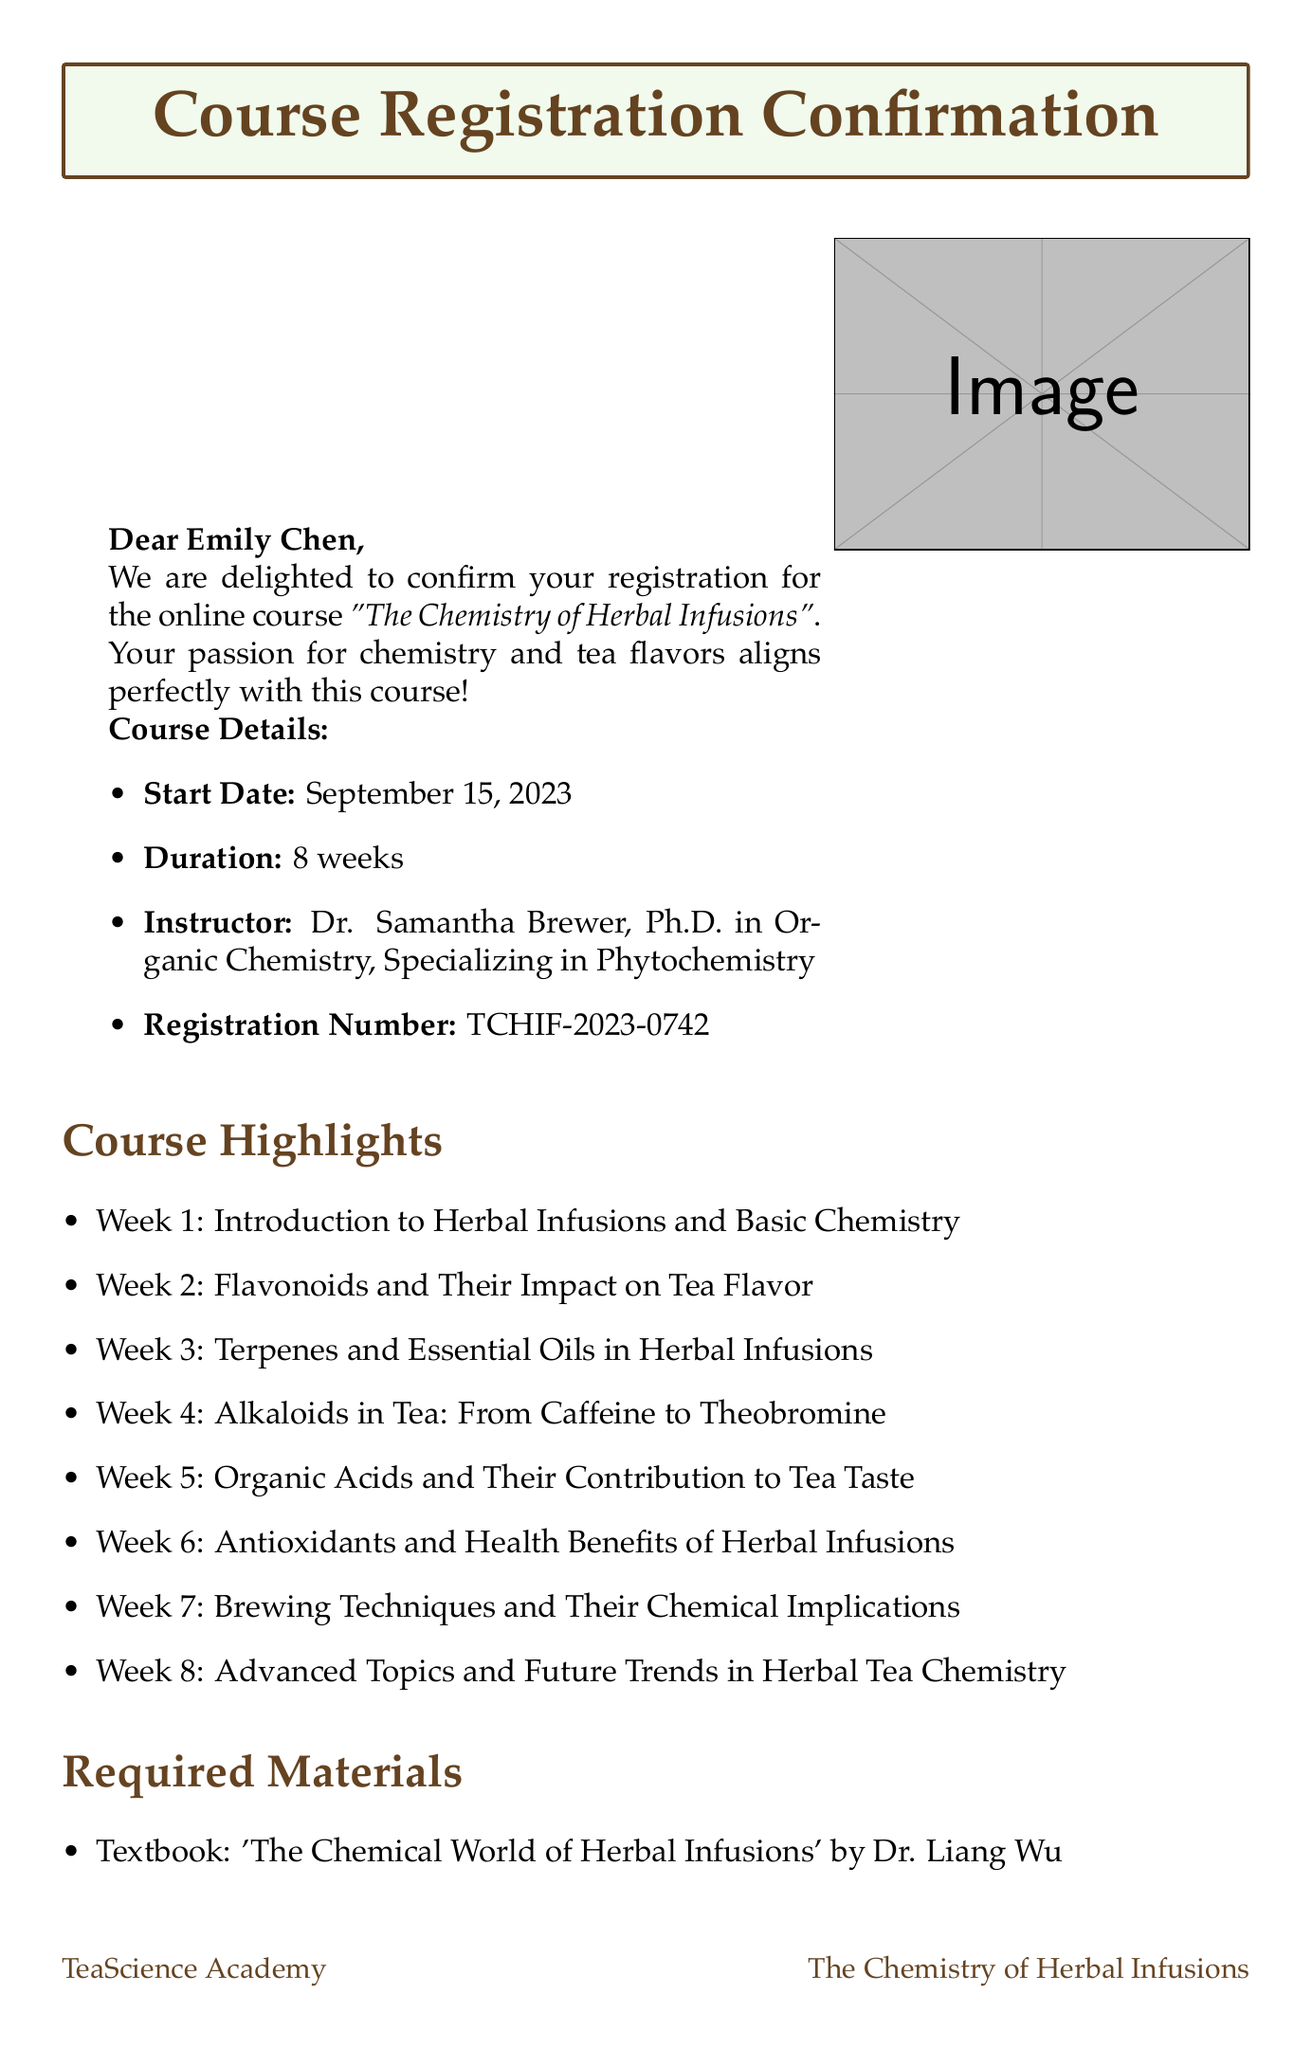What is the course title? The course title is specifically mentioned in the document as "The Chemistry of Herbal Infusions".
Answer: The Chemistry of Herbal Infusions Who is the instructor for the course? The document states that the instructor's name is Dr. Samantha Brewer, along with her credentials.
Answer: Dr. Samantha Brewer What is the course duration? The duration of the course is explicitly stated in the document as 8 weeks.
Answer: 8 weeks What percentage of the final grade is based on the final project? The document outlines the assessment methods and specifies that the final project accounts for 30% of the grade.
Answer: 30% What critical chemical concept is covered in Week 5? In Week 5, the topic focuses on organic acids and their contribution to tea taste, which is a key chemical concept.
Answer: Organic Acids What kind of calculator is recommended for the course? The required materials list a recommendation for a basic chemistry calculator.
Answer: Casio fx-115ES PLUS What is the registration confirmation number? The email contains the registration confirmation number for tracking enrollment in the course.
Answer: TCHIF-2023-0742 What online resource is provided through the course portal? The document mentions a specific journal that students will have access to through the course portal.
Answer: Journal of Agricultural and Food Chemistry How many weeks does the course start? The start date of the course is highlighted in the document, indicating its specific week count.
Answer: September 15, 2023 